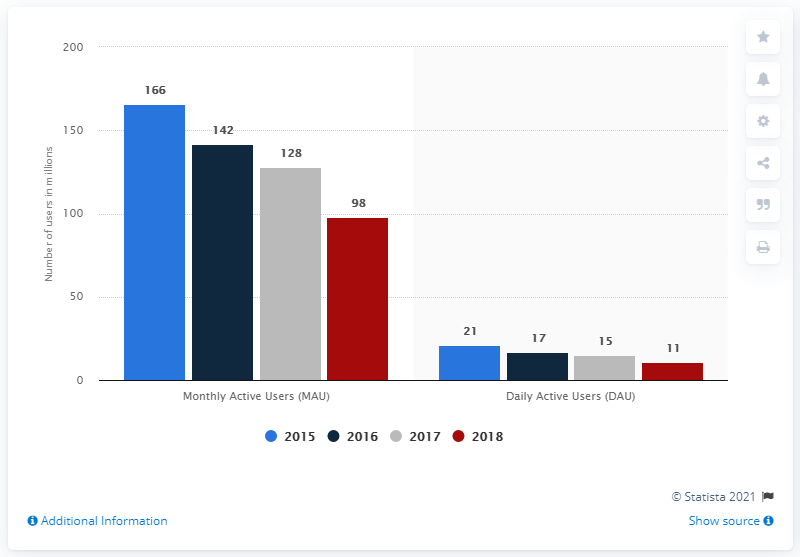Give some essential details in this illustration. In 2018, Gameloft had 98 million monthly active users (MAUs). In 2018, Gameloft had 11 million daily active users (DAU). 